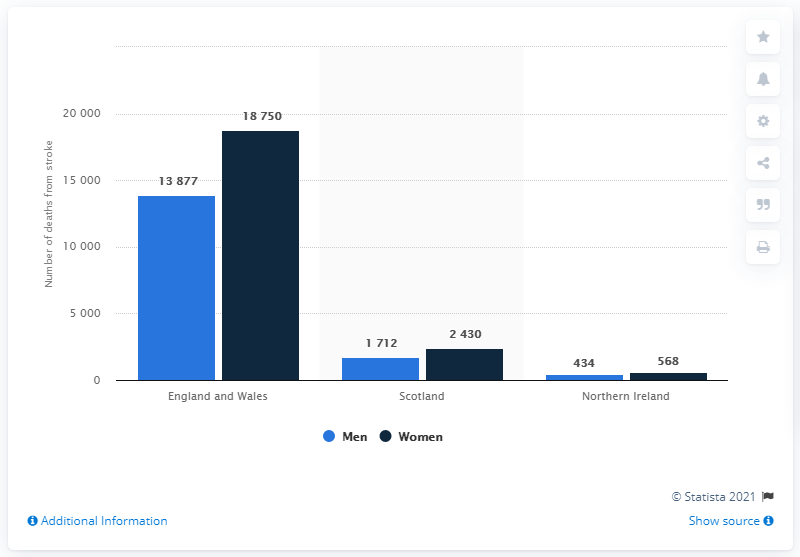Outline some significant characteristics in this image. In Scotland, there is a ratio of 0.7142857143 between the number of men and women. The chart shows a comparison between the value of A in Northern Ireland and the value of women in Northern Ireland. The value of A is 434, while the value of women is 568. Therefore, the category represented by the blue bar in the chart is likely Northern Ireland. 